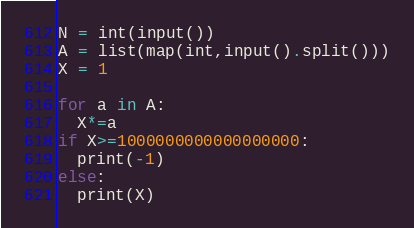Convert code to text. <code><loc_0><loc_0><loc_500><loc_500><_Python_>N = int(input())
A = list(map(int,input().split()))
X = 1

for a in A:
  X*=a
if X>=1000000000000000000:
  print(-1)
else:
  print(X)</code> 